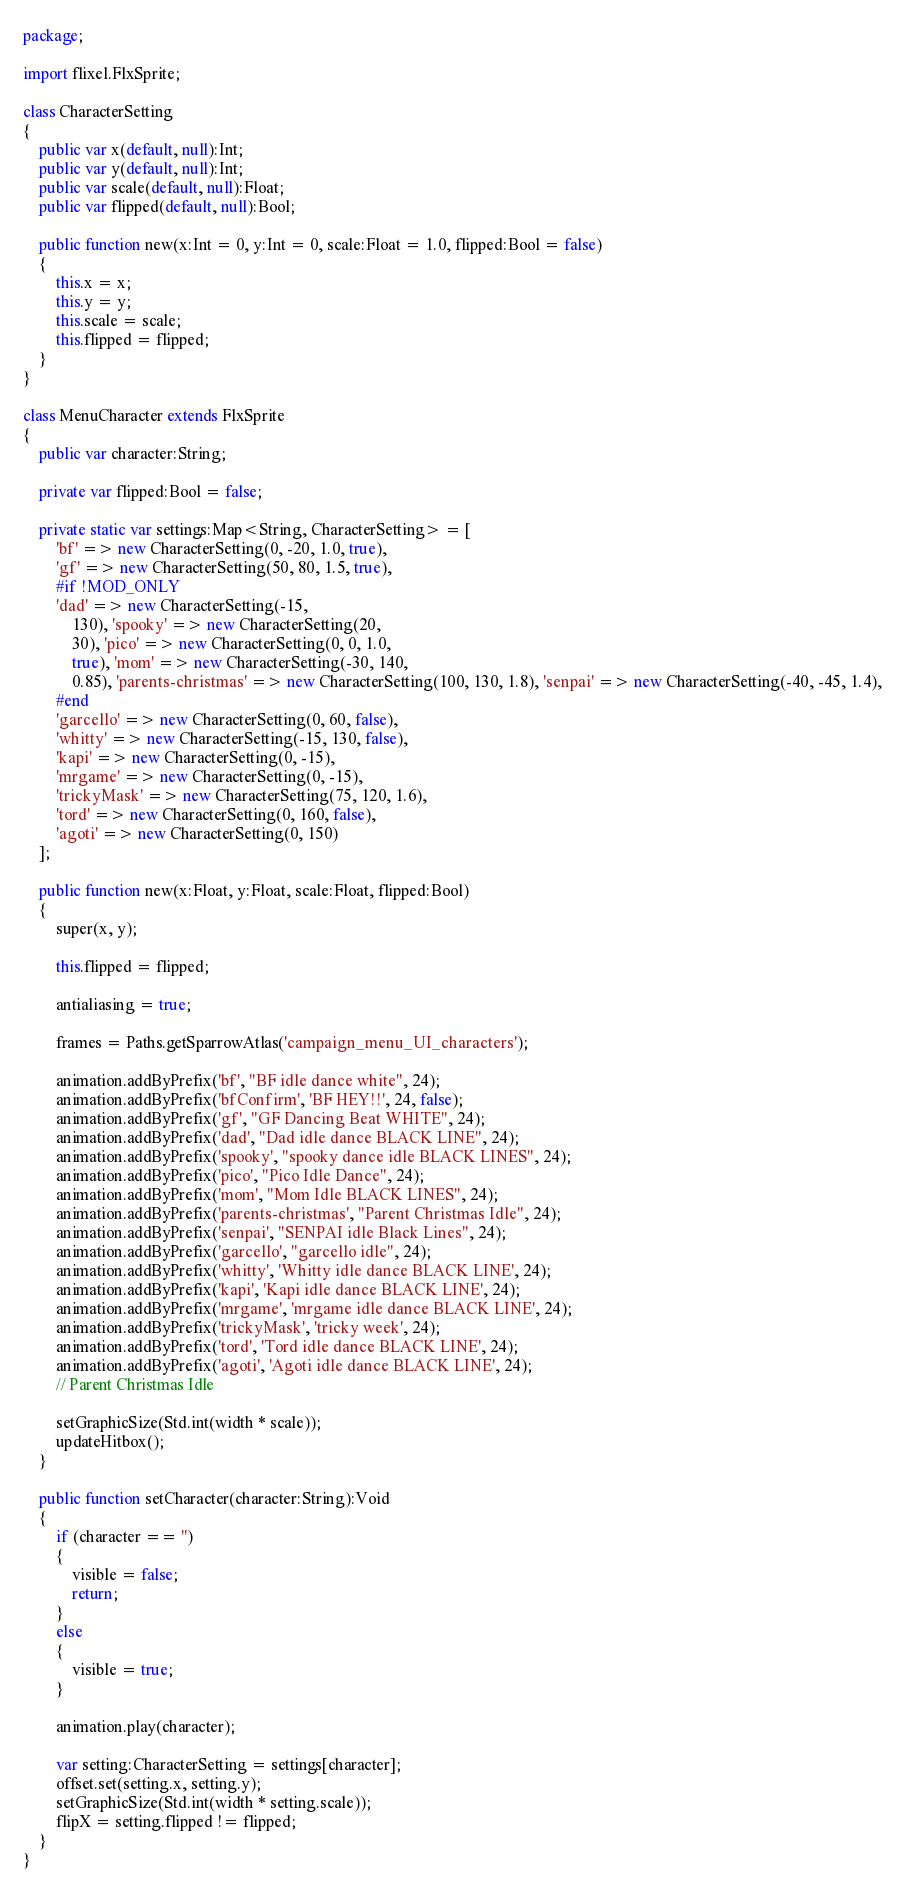Convert code to text. <code><loc_0><loc_0><loc_500><loc_500><_Haxe_>package;

import flixel.FlxSprite;

class CharacterSetting
{
	public var x(default, null):Int;
	public var y(default, null):Int;
	public var scale(default, null):Float;
	public var flipped(default, null):Bool;

	public function new(x:Int = 0, y:Int = 0, scale:Float = 1.0, flipped:Bool = false)
	{
		this.x = x;
		this.y = y;
		this.scale = scale;
		this.flipped = flipped;
	}
}

class MenuCharacter extends FlxSprite
{
	public var character:String;

	private var flipped:Bool = false;

	private static var settings:Map<String, CharacterSetting> = [
		'bf' => new CharacterSetting(0, -20, 1.0, true),
		'gf' => new CharacterSetting(50, 80, 1.5, true),
		#if !MOD_ONLY
		'dad' => new CharacterSetting(-15,
			130), 'spooky' => new CharacterSetting(20,
			30), 'pico' => new CharacterSetting(0, 0, 1.0,
			true), 'mom' => new CharacterSetting(-30, 140,
			0.85), 'parents-christmas' => new CharacterSetting(100, 130, 1.8), 'senpai' => new CharacterSetting(-40, -45, 1.4),
		#end
		'garcello' => new CharacterSetting(0, 60, false),
		'whitty' => new CharacterSetting(-15, 130, false),
		'kapi' => new CharacterSetting(0, -15),
		'mrgame' => new CharacterSetting(0, -15),
		'trickyMask' => new CharacterSetting(75, 120, 1.6),
		'tord' => new CharacterSetting(0, 160, false),
		'agoti' => new CharacterSetting(0, 150)
	];

	public function new(x:Float, y:Float, scale:Float, flipped:Bool)
	{
		super(x, y);

		this.flipped = flipped;

		antialiasing = true;

		frames = Paths.getSparrowAtlas('campaign_menu_UI_characters');

		animation.addByPrefix('bf', "BF idle dance white", 24);
		animation.addByPrefix('bfConfirm', 'BF HEY!!', 24, false);
		animation.addByPrefix('gf', "GF Dancing Beat WHITE", 24);
		animation.addByPrefix('dad', "Dad idle dance BLACK LINE", 24);
		animation.addByPrefix('spooky', "spooky dance idle BLACK LINES", 24);
		animation.addByPrefix('pico', "Pico Idle Dance", 24);
		animation.addByPrefix('mom', "Mom Idle BLACK LINES", 24);
		animation.addByPrefix('parents-christmas', "Parent Christmas Idle", 24);
		animation.addByPrefix('senpai', "SENPAI idle Black Lines", 24);
		animation.addByPrefix('garcello', "garcello idle", 24);
		animation.addByPrefix('whitty', 'Whitty idle dance BLACK LINE', 24);
		animation.addByPrefix('kapi', 'Kapi idle dance BLACK LINE', 24);
		animation.addByPrefix('mrgame', 'mrgame idle dance BLACK LINE', 24);
		animation.addByPrefix('trickyMask', 'tricky week', 24);
		animation.addByPrefix('tord', 'Tord idle dance BLACK LINE', 24);
		animation.addByPrefix('agoti', 'Agoti idle dance BLACK LINE', 24);
		// Parent Christmas Idle

		setGraphicSize(Std.int(width * scale));
		updateHitbox();
	}

	public function setCharacter(character:String):Void
	{
		if (character == '')
		{
			visible = false;
			return;
		}
		else
		{
			visible = true;
		}

		animation.play(character);

		var setting:CharacterSetting = settings[character];
		offset.set(setting.x, setting.y);
		setGraphicSize(Std.int(width * setting.scale));
		flipX = setting.flipped != flipped;
	}
}
</code> 